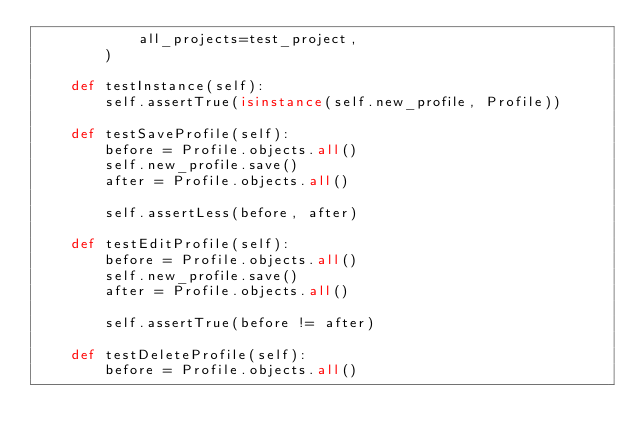Convert code to text. <code><loc_0><loc_0><loc_500><loc_500><_Python_>            all_projects=test_project,
        )

    def testInstance(self):
        self.assertTrue(isinstance(self.new_profile, Profile))

    def testSaveProfile(self):
        before = Profile.objects.all()
        self.new_profile.save()
        after = Profile.objects.all()

        self.assertLess(before, after)

    def testEditProfile(self):
        before = Profile.objects.all()
        self.new_profile.save()
        after = Profile.objects.all()

        self.assertTrue(before != after)

    def testDeleteProfile(self):
        before = Profile.objects.all()</code> 